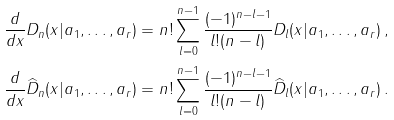Convert formula to latex. <formula><loc_0><loc_0><loc_500><loc_500>\frac { d } { d x } D _ { n } ( x | a _ { 1 } , \dots , a _ { r } ) & = n ! \sum _ { l = 0 } ^ { n - 1 } \frac { ( - 1 ) ^ { n - l - 1 } } { l ! ( n - l ) } D _ { l } ( x | a _ { 1 } , \dots , a _ { r } ) \, , \\ \frac { d } { d x } \widehat { D } _ { n } ( x | a _ { 1 } , \dots , a _ { r } ) & = n ! \sum _ { l = 0 } ^ { n - 1 } \frac { ( - 1 ) ^ { n - l - 1 } } { l ! ( n - l ) } \widehat { D } _ { l } ( x | a _ { 1 } , \dots , a _ { r } ) \, .</formula> 